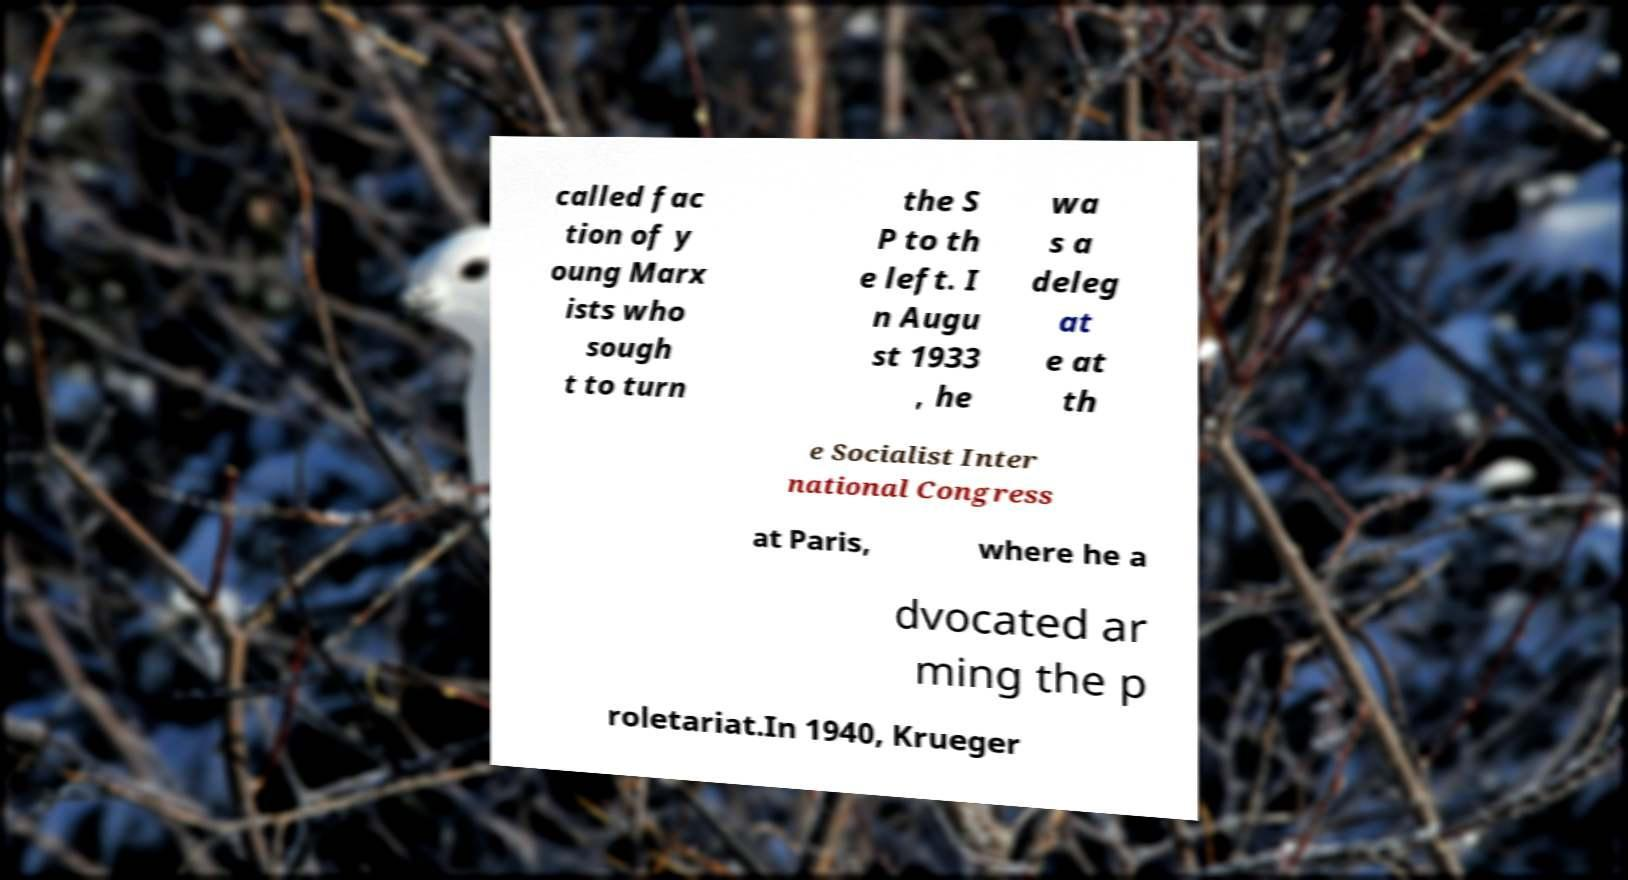For documentation purposes, I need the text within this image transcribed. Could you provide that? called fac tion of y oung Marx ists who sough t to turn the S P to th e left. I n Augu st 1933 , he wa s a deleg at e at th e Socialist Inter national Congress at Paris, where he a dvocated ar ming the p roletariat.In 1940, Krueger 